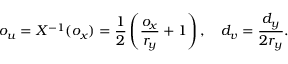<formula> <loc_0><loc_0><loc_500><loc_500>o _ { u } = X ^ { - 1 } ( o _ { x } ) = \frac { 1 } { 2 } \left ( \frac { o _ { x } } { r _ { y } } + 1 \right ) , \quad d _ { v } = \frac { d _ { y } } { 2 r _ { y } } .</formula> 